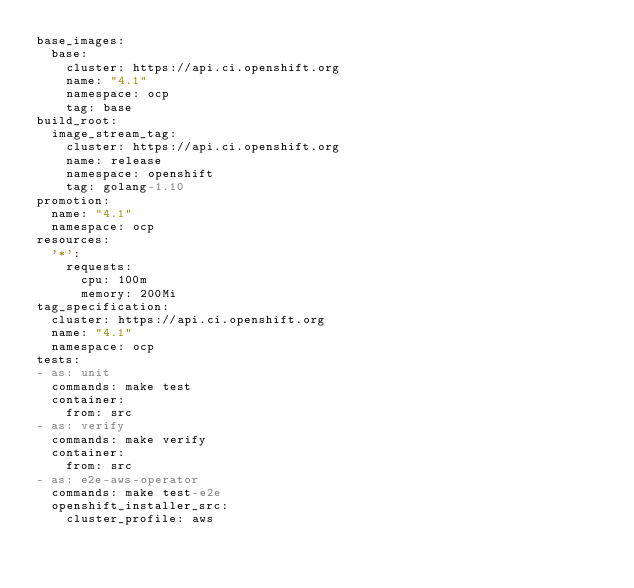<code> <loc_0><loc_0><loc_500><loc_500><_YAML_>base_images:
  base:
    cluster: https://api.ci.openshift.org
    name: "4.1"
    namespace: ocp
    tag: base
build_root:
  image_stream_tag:
    cluster: https://api.ci.openshift.org
    name: release
    namespace: openshift
    tag: golang-1.10
promotion:
  name: "4.1"
  namespace: ocp
resources:
  '*':
    requests:
      cpu: 100m
      memory: 200Mi
tag_specification:
  cluster: https://api.ci.openshift.org
  name: "4.1"
  namespace: ocp
tests:
- as: unit
  commands: make test
  container:
    from: src
- as: verify
  commands: make verify
  container:
    from: src
- as: e2e-aws-operator
  commands: make test-e2e
  openshift_installer_src:
    cluster_profile: aws
</code> 